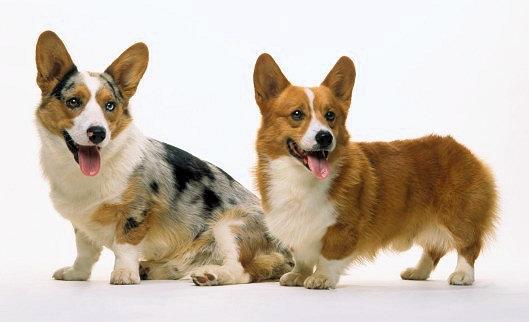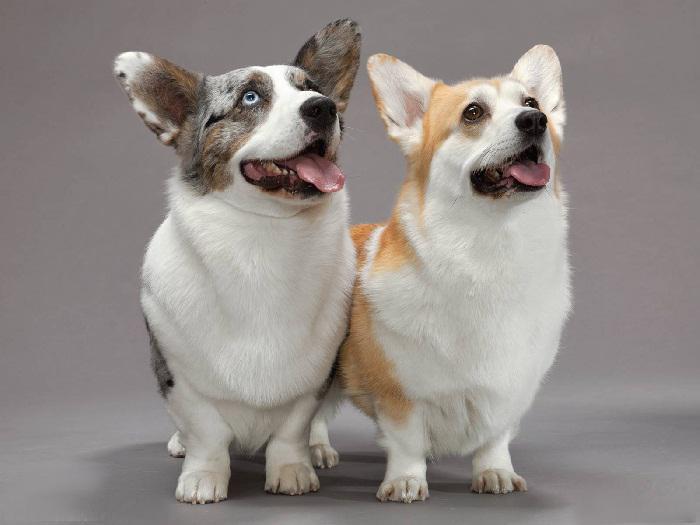The first image is the image on the left, the second image is the image on the right. For the images shown, is this caption "The left image contains exactly two dogs." true? Answer yes or no. Yes. The first image is the image on the left, the second image is the image on the right. For the images displayed, is the sentence "There are four dogs in the image pair." factually correct? Answer yes or no. Yes. 